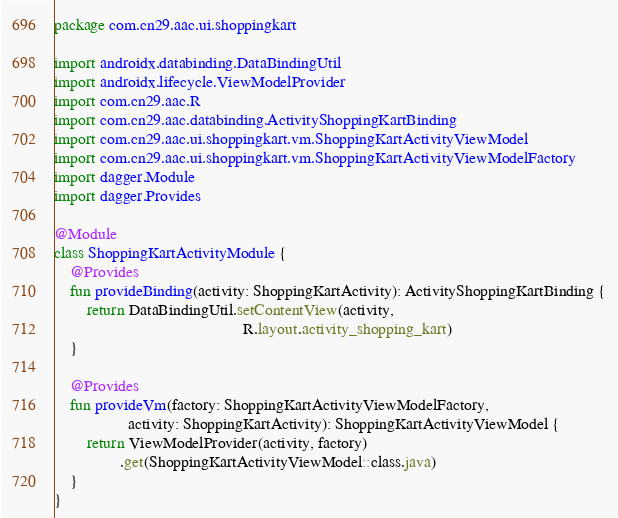<code> <loc_0><loc_0><loc_500><loc_500><_Kotlin_>package com.cn29.aac.ui.shoppingkart

import androidx.databinding.DataBindingUtil
import androidx.lifecycle.ViewModelProvider
import com.cn29.aac.R
import com.cn29.aac.databinding.ActivityShoppingKartBinding
import com.cn29.aac.ui.shoppingkart.vm.ShoppingKartActivityViewModel
import com.cn29.aac.ui.shoppingkart.vm.ShoppingKartActivityViewModelFactory
import dagger.Module
import dagger.Provides

@Module
class ShoppingKartActivityModule {
    @Provides
    fun provideBinding(activity: ShoppingKartActivity): ActivityShoppingKartBinding {
        return DataBindingUtil.setContentView(activity,
                                              R.layout.activity_shopping_kart)
    }

    @Provides
    fun provideVm(factory: ShoppingKartActivityViewModelFactory,
                  activity: ShoppingKartActivity): ShoppingKartActivityViewModel {
        return ViewModelProvider(activity, factory)
                .get(ShoppingKartActivityViewModel::class.java)
    }
}</code> 